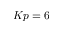<formula> <loc_0><loc_0><loc_500><loc_500>K p = 6</formula> 